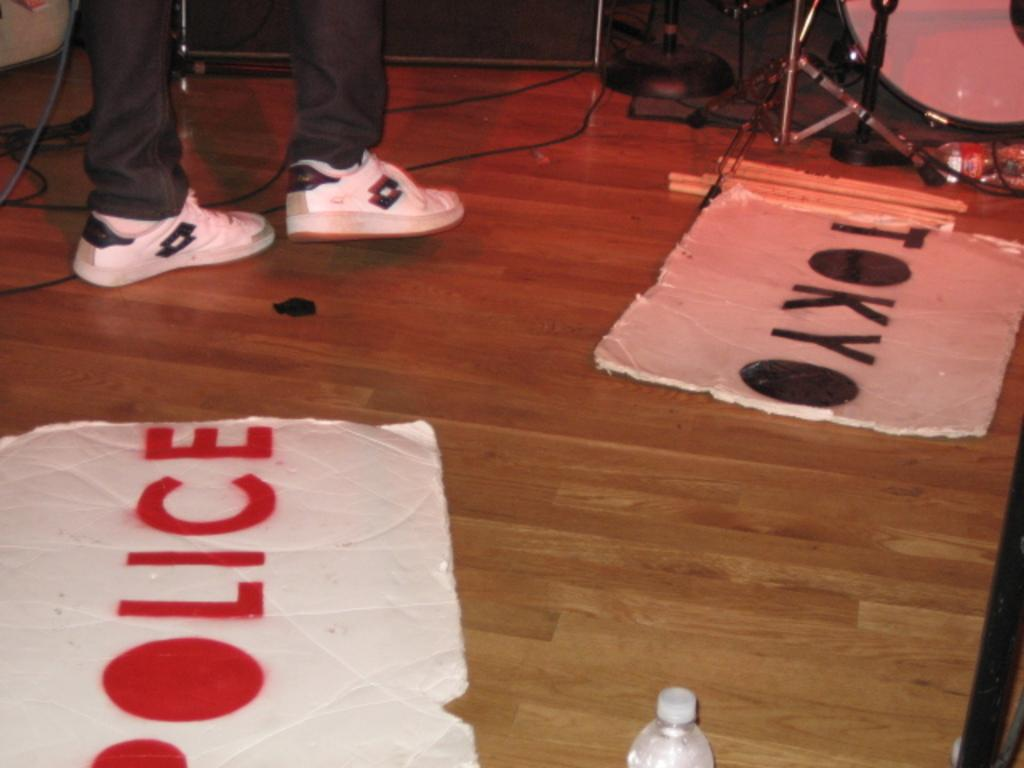What part of a person can be seen in the image? There are legs of a person visible in the image. What type of furniture is present in the image? There are chairs in the image. What type of objects are made of wood in the image? There are boards in the image. What type of containers are present in the image? There are bottles in the image. What other objects can be seen in the image? There are other objects in the image. What type of jewel is the pet wearing in the image? There is no pet or jewel present in the image. 